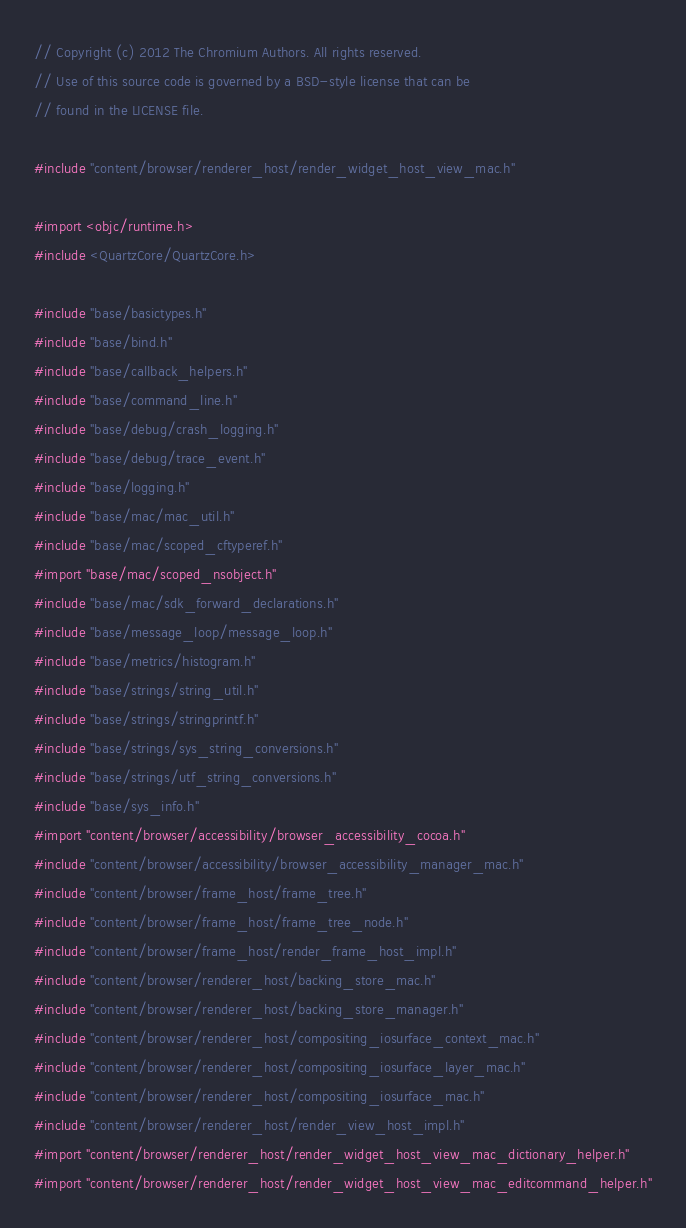<code> <loc_0><loc_0><loc_500><loc_500><_ObjectiveC_>// Copyright (c) 2012 The Chromium Authors. All rights reserved.
// Use of this source code is governed by a BSD-style license that can be
// found in the LICENSE file.

#include "content/browser/renderer_host/render_widget_host_view_mac.h"

#import <objc/runtime.h>
#include <QuartzCore/QuartzCore.h>

#include "base/basictypes.h"
#include "base/bind.h"
#include "base/callback_helpers.h"
#include "base/command_line.h"
#include "base/debug/crash_logging.h"
#include "base/debug/trace_event.h"
#include "base/logging.h"
#include "base/mac/mac_util.h"
#include "base/mac/scoped_cftyperef.h"
#import "base/mac/scoped_nsobject.h"
#include "base/mac/sdk_forward_declarations.h"
#include "base/message_loop/message_loop.h"
#include "base/metrics/histogram.h"
#include "base/strings/string_util.h"
#include "base/strings/stringprintf.h"
#include "base/strings/sys_string_conversions.h"
#include "base/strings/utf_string_conversions.h"
#include "base/sys_info.h"
#import "content/browser/accessibility/browser_accessibility_cocoa.h"
#include "content/browser/accessibility/browser_accessibility_manager_mac.h"
#include "content/browser/frame_host/frame_tree.h"
#include "content/browser/frame_host/frame_tree_node.h"
#include "content/browser/frame_host/render_frame_host_impl.h"
#include "content/browser/renderer_host/backing_store_mac.h"
#include "content/browser/renderer_host/backing_store_manager.h"
#include "content/browser/renderer_host/compositing_iosurface_context_mac.h"
#include "content/browser/renderer_host/compositing_iosurface_layer_mac.h"
#include "content/browser/renderer_host/compositing_iosurface_mac.h"
#include "content/browser/renderer_host/render_view_host_impl.h"
#import "content/browser/renderer_host/render_widget_host_view_mac_dictionary_helper.h"
#import "content/browser/renderer_host/render_widget_host_view_mac_editcommand_helper.h"</code> 